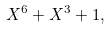Convert formula to latex. <formula><loc_0><loc_0><loc_500><loc_500>X ^ { 6 } + X ^ { 3 } + 1 ,</formula> 